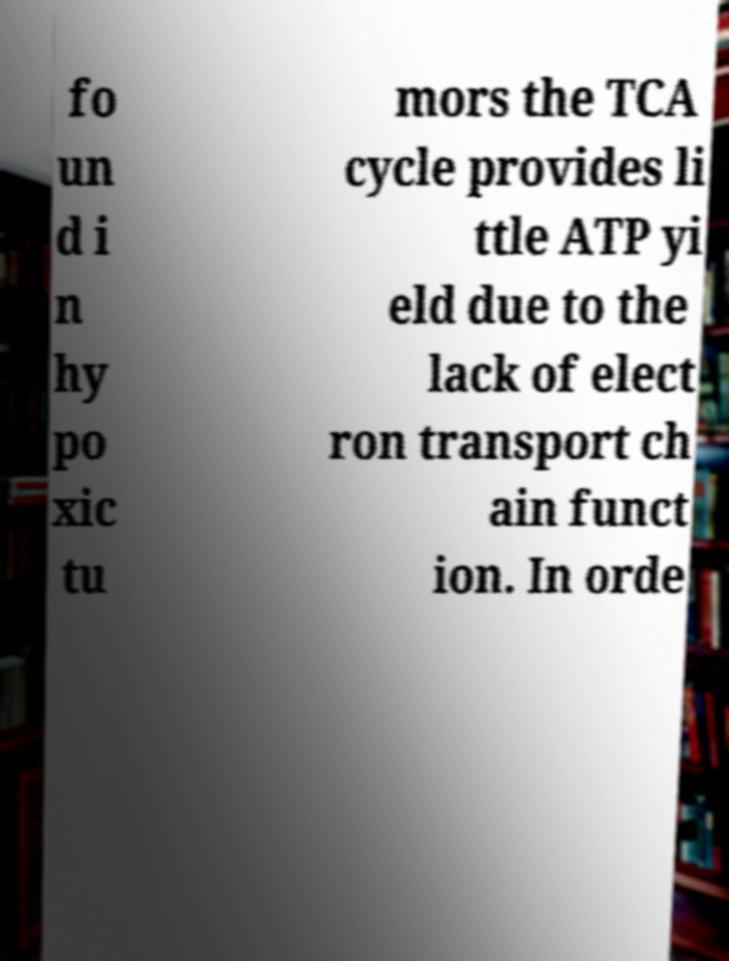What messages or text are displayed in this image? I need them in a readable, typed format. fo un d i n hy po xic tu mors the TCA cycle provides li ttle ATP yi eld due to the lack of elect ron transport ch ain funct ion. In orde 